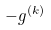<formula> <loc_0><loc_0><loc_500><loc_500>- g ^ { ( k ) }</formula> 